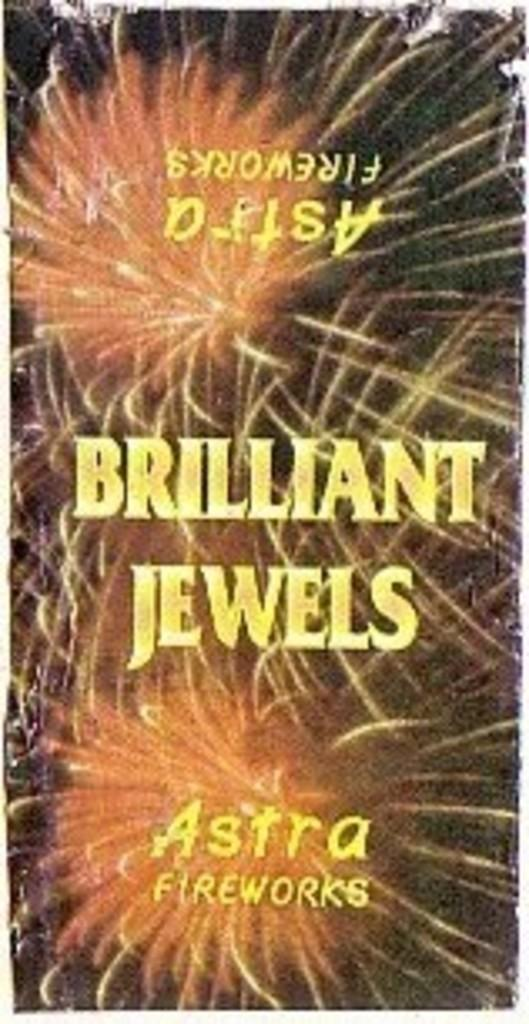<image>
Write a terse but informative summary of the picture. An ad for Astra fireworks shows bright orange fireworks. 